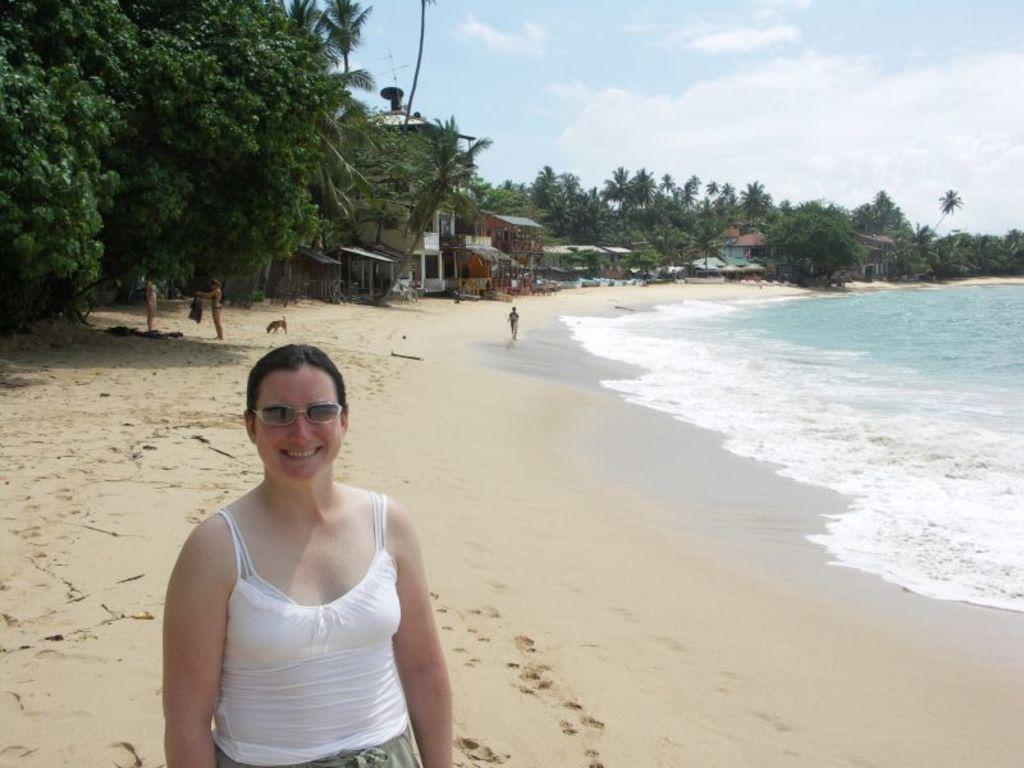What type of natural vegetation can be seen in the image? There are trees in the image. What type of structures are present in the image? There are small huts in the image. How many people are in the image? There are four people in the image. What type of animal is present in the image? A dog is present in the image. What can be inferred about the location based on the image? There is a beach in the image, and water is visible. What evidence of activity can be seen on the ground in the image? There are footprints on the ground in the image. What type of stocking is the dog wearing in the image? There is no stocking present on the dog in the image. How does the brake system work on the beach in the image? There is no brake system present in the image, as it is a natural setting with no vehicles or machinery. 